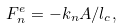<formula> <loc_0><loc_0><loc_500><loc_500>F ^ { e } _ { n } = - k _ { n } A / l _ { c } ,</formula> 